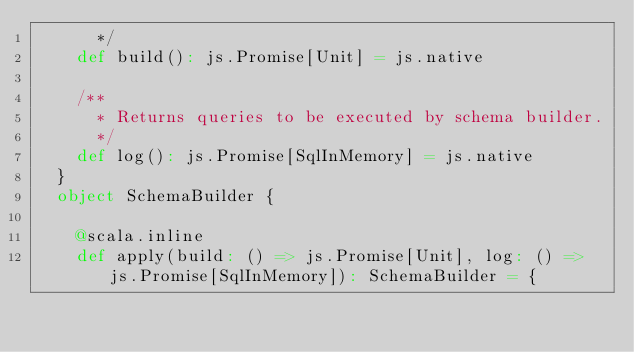Convert code to text. <code><loc_0><loc_0><loc_500><loc_500><_Scala_>      */
    def build(): js.Promise[Unit] = js.native
    
    /**
      * Returns queries to be executed by schema builder.
      */
    def log(): js.Promise[SqlInMemory] = js.native
  }
  object SchemaBuilder {
    
    @scala.inline
    def apply(build: () => js.Promise[Unit], log: () => js.Promise[SqlInMemory]): SchemaBuilder = {</code> 